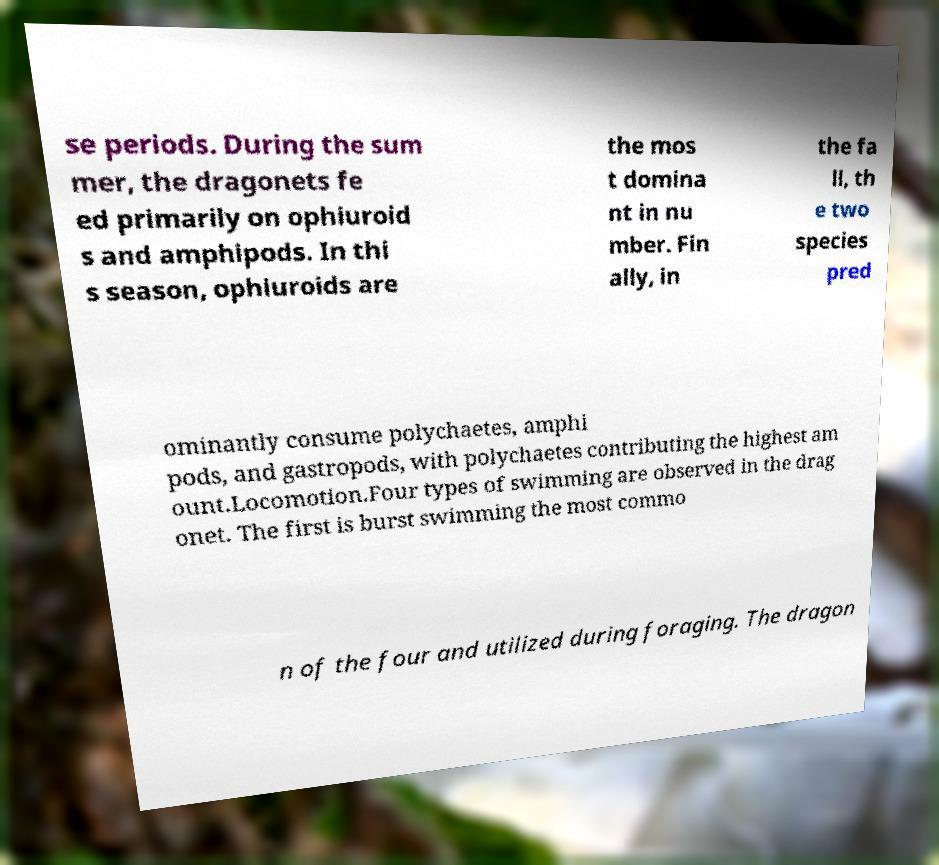Please identify and transcribe the text found in this image. se periods. During the sum mer, the dragonets fe ed primarily on ophiuroid s and amphipods. In thi s season, ophiuroids are the mos t domina nt in nu mber. Fin ally, in the fa ll, th e two species pred ominantly consume polychaetes, amphi pods, and gastropods, with polychaetes contributing the highest am ount.Locomotion.Four types of swimming are observed in the drag onet. The first is burst swimming the most commo n of the four and utilized during foraging. The dragon 